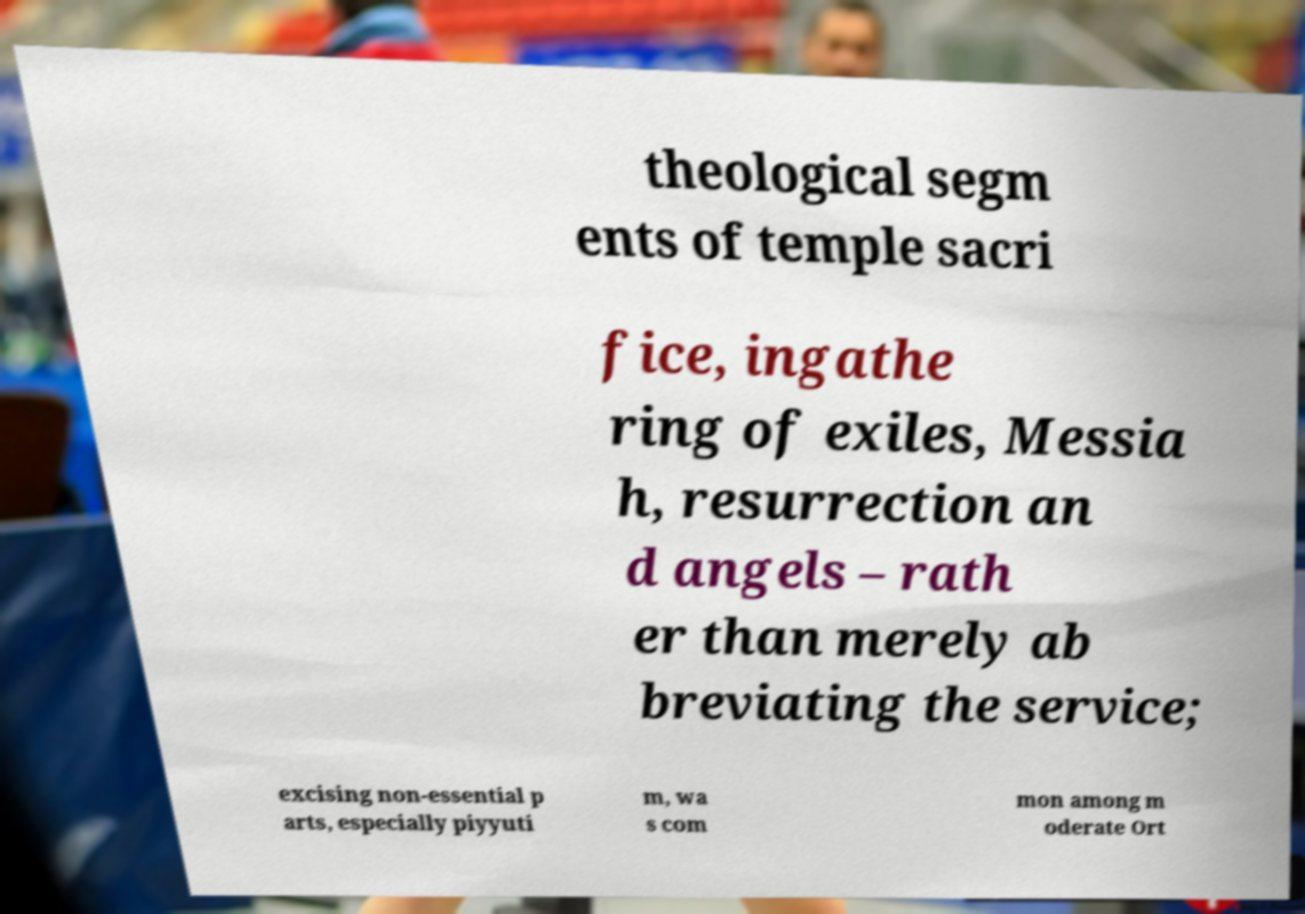Can you accurately transcribe the text from the provided image for me? theological segm ents of temple sacri fice, ingathe ring of exiles, Messia h, resurrection an d angels – rath er than merely ab breviating the service; excising non-essential p arts, especially piyyuti m, wa s com mon among m oderate Ort 